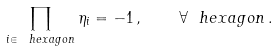<formula> <loc_0><loc_0><loc_500><loc_500>\prod _ { i \in \ h e x a g o n } \eta _ { i } = - 1 \, , \quad \forall \ h e x a g o n \, .</formula> 